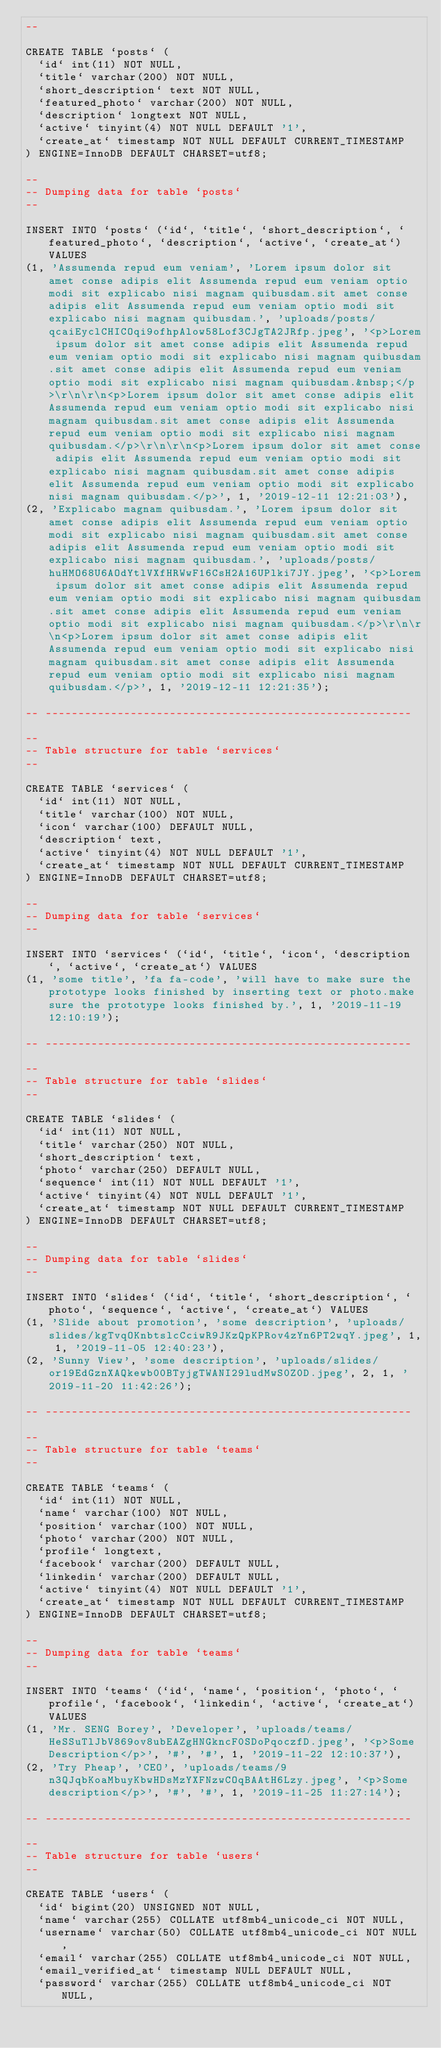Convert code to text. <code><loc_0><loc_0><loc_500><loc_500><_SQL_>--

CREATE TABLE `posts` (
  `id` int(11) NOT NULL,
  `title` varchar(200) NOT NULL,
  `short_description` text NOT NULL,
  `featured_photo` varchar(200) NOT NULL,
  `description` longtext NOT NULL,
  `active` tinyint(4) NOT NULL DEFAULT '1',
  `create_at` timestamp NOT NULL DEFAULT CURRENT_TIMESTAMP
) ENGINE=InnoDB DEFAULT CHARSET=utf8;

--
-- Dumping data for table `posts`
--

INSERT INTO `posts` (`id`, `title`, `short_description`, `featured_photo`, `description`, `active`, `create_at`) VALUES
(1, 'Assumenda repud eum veniam', 'Lorem ipsum dolor sit amet conse adipis elit Assumenda repud eum veniam optio modi sit explicabo nisi magnam quibusdam.sit amet conse adipis elit Assumenda repud eum veniam optio modi sit explicabo nisi magnam quibusdam.', 'uploads/posts/qcaiEyclCHICOqi9ofhpAlow58Lof3CJgTA2JRfp.jpeg', '<p>Lorem ipsum dolor sit amet conse adipis elit Assumenda repud eum veniam optio modi sit explicabo nisi magnam quibusdam.sit amet conse adipis elit Assumenda repud eum veniam optio modi sit explicabo nisi magnam quibusdam.&nbsp;</p>\r\n\r\n<p>Lorem ipsum dolor sit amet conse adipis elit Assumenda repud eum veniam optio modi sit explicabo nisi magnam quibusdam.sit amet conse adipis elit Assumenda repud eum veniam optio modi sit explicabo nisi magnam quibusdam.</p>\r\n\r\n<p>Lorem ipsum dolor sit amet conse adipis elit Assumenda repud eum veniam optio modi sit explicabo nisi magnam quibusdam.sit amet conse adipis elit Assumenda repud eum veniam optio modi sit explicabo nisi magnam quibusdam.</p>', 1, '2019-12-11 12:21:03'),
(2, 'Explicabo magnam quibusdam.', 'Lorem ipsum dolor sit amet conse adipis elit Assumenda repud eum veniam optio modi sit explicabo nisi magnam quibusdam.sit amet conse adipis elit Assumenda repud eum veniam optio modi sit explicabo nisi magnam quibusdam.', 'uploads/posts/huHMO68U6AOdYtlVXfHRWwF16CsH2A16UPlki7JY.jpeg', '<p>Lorem ipsum dolor sit amet conse adipis elit Assumenda repud eum veniam optio modi sit explicabo nisi magnam quibusdam.sit amet conse adipis elit Assumenda repud eum veniam optio modi sit explicabo nisi magnam quibusdam.</p>\r\n\r\n<p>Lorem ipsum dolor sit amet conse adipis elit Assumenda repud eum veniam optio modi sit explicabo nisi magnam quibusdam.sit amet conse adipis elit Assumenda repud eum veniam optio modi sit explicabo nisi magnam quibusdam.</p>', 1, '2019-12-11 12:21:35');

-- --------------------------------------------------------

--
-- Table structure for table `services`
--

CREATE TABLE `services` (
  `id` int(11) NOT NULL,
  `title` varchar(100) NOT NULL,
  `icon` varchar(100) DEFAULT NULL,
  `description` text,
  `active` tinyint(4) NOT NULL DEFAULT '1',
  `create_at` timestamp NOT NULL DEFAULT CURRENT_TIMESTAMP
) ENGINE=InnoDB DEFAULT CHARSET=utf8;

--
-- Dumping data for table `services`
--

INSERT INTO `services` (`id`, `title`, `icon`, `description`, `active`, `create_at`) VALUES
(1, 'some title', 'fa fa-code', 'will have to make sure the prototype looks finished by inserting text or photo.make sure the prototype looks finished by.', 1, '2019-11-19 12:10:19');

-- --------------------------------------------------------

--
-- Table structure for table `slides`
--

CREATE TABLE `slides` (
  `id` int(11) NOT NULL,
  `title` varchar(250) NOT NULL,
  `short_description` text,
  `photo` varchar(250) DEFAULT NULL,
  `sequence` int(11) NOT NULL DEFAULT '1',
  `active` tinyint(4) NOT NULL DEFAULT '1',
  `create_at` timestamp NOT NULL DEFAULT CURRENT_TIMESTAMP
) ENGINE=InnoDB DEFAULT CHARSET=utf8;

--
-- Dumping data for table `slides`
--

INSERT INTO `slides` (`id`, `title`, `short_description`, `photo`, `sequence`, `active`, `create_at`) VALUES
(1, 'Slide about promotion', 'some description', 'uploads/slides/kgTvqOKnbtslcCciwR9JKzQpKPRov4zYn6PT2wqY.jpeg', 1, 1, '2019-11-05 12:40:23'),
(2, 'Sunny View', 'some description', 'uploads/slides/or19EdGznXAQkewb00BTyjgTWANI29ludMwS0Z0D.jpeg', 2, 1, '2019-11-20 11:42:26');

-- --------------------------------------------------------

--
-- Table structure for table `teams`
--

CREATE TABLE `teams` (
  `id` int(11) NOT NULL,
  `name` varchar(100) NOT NULL,
  `position` varchar(100) NOT NULL,
  `photo` varchar(200) NOT NULL,
  `profile` longtext,
  `facebook` varchar(200) DEFAULT NULL,
  `linkedin` varchar(200) DEFAULT NULL,
  `active` tinyint(4) NOT NULL DEFAULT '1',
  `create_at` timestamp NOT NULL DEFAULT CURRENT_TIMESTAMP
) ENGINE=InnoDB DEFAULT CHARSET=utf8;

--
-- Dumping data for table `teams`
--

INSERT INTO `teams` (`id`, `name`, `position`, `photo`, `profile`, `facebook`, `linkedin`, `active`, `create_at`) VALUES
(1, 'Mr. SENG Borey', 'Developer', 'uploads/teams/HeSSuTlJbV869ov8ubEAZgHNGkncF0SDoPqoczfD.jpeg', '<p>Some Description</p>', '#', '#', 1, '2019-11-22 12:10:37'),
(2, 'Try Pheap', 'CEO', 'uploads/teams/9n3QJqbKoaMbuyKbwHDsMzYXFNzwCOqBAAtH6Lzy.jpeg', '<p>Some description</p>', '#', '#', 1, '2019-11-25 11:27:14');

-- --------------------------------------------------------

--
-- Table structure for table `users`
--

CREATE TABLE `users` (
  `id` bigint(20) UNSIGNED NOT NULL,
  `name` varchar(255) COLLATE utf8mb4_unicode_ci NOT NULL,
  `username` varchar(50) COLLATE utf8mb4_unicode_ci NOT NULL,
  `email` varchar(255) COLLATE utf8mb4_unicode_ci NOT NULL,
  `email_verified_at` timestamp NULL DEFAULT NULL,
  `password` varchar(255) COLLATE utf8mb4_unicode_ci NOT NULL,</code> 